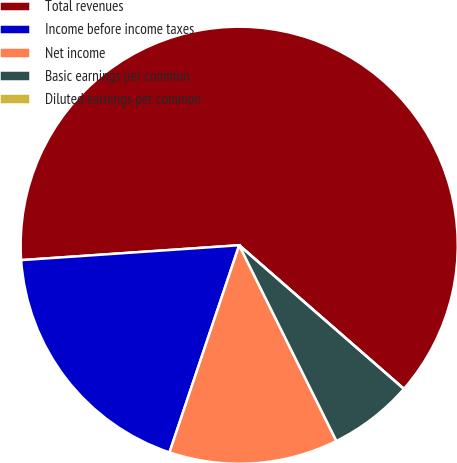Convert chart to OTSL. <chart><loc_0><loc_0><loc_500><loc_500><pie_chart><fcel>Total revenues<fcel>Income before income taxes<fcel>Net income<fcel>Basic earnings per common<fcel>Diluted earnings per common<nl><fcel>62.5%<fcel>18.75%<fcel>12.5%<fcel>6.25%<fcel>0.0%<nl></chart> 